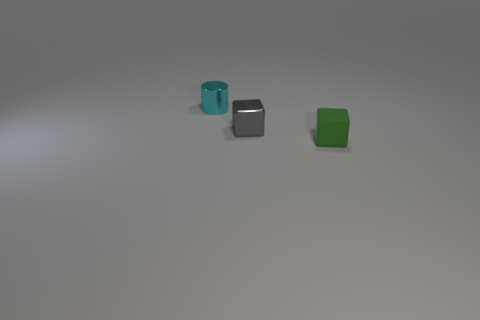Is there anything else that has the same material as the green thing?
Your answer should be very brief. No. There is a metal thing that is right of the tiny shiny thing that is behind the small gray metallic thing; how big is it?
Offer a very short reply. Small. The rubber object has what color?
Keep it short and to the point. Green. There is a thing that is behind the tiny gray block; what number of metal objects are on the right side of it?
Give a very brief answer. 1. There is a tiny cube that is behind the green matte cube; is there a gray thing that is on the right side of it?
Your answer should be very brief. No. Are there any cylinders right of the small gray cube?
Your response must be concise. No. There is a shiny thing that is in front of the small cyan cylinder; is it the same shape as the rubber object?
Ensure brevity in your answer.  Yes. What number of gray metallic things are the same shape as the tiny cyan object?
Your answer should be very brief. 0. Are there any brown objects made of the same material as the cyan cylinder?
Offer a very short reply. No. What is the material of the small cube behind the object in front of the tiny metallic cube?
Give a very brief answer. Metal. 